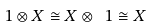<formula> <loc_0><loc_0><loc_500><loc_500>\ 1 \otimes X \cong X \otimes \ 1 \cong X</formula> 